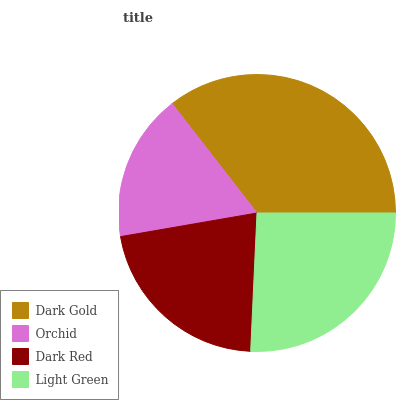Is Orchid the minimum?
Answer yes or no. Yes. Is Dark Gold the maximum?
Answer yes or no. Yes. Is Dark Red the minimum?
Answer yes or no. No. Is Dark Red the maximum?
Answer yes or no. No. Is Dark Red greater than Orchid?
Answer yes or no. Yes. Is Orchid less than Dark Red?
Answer yes or no. Yes. Is Orchid greater than Dark Red?
Answer yes or no. No. Is Dark Red less than Orchid?
Answer yes or no. No. Is Light Green the high median?
Answer yes or no. Yes. Is Dark Red the low median?
Answer yes or no. Yes. Is Dark Red the high median?
Answer yes or no. No. Is Light Green the low median?
Answer yes or no. No. 